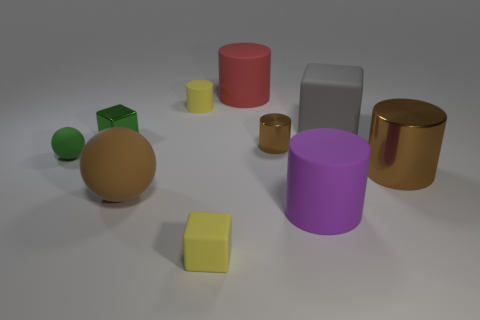What is the shape of the large purple thing that is made of the same material as the large sphere?
Your response must be concise. Cylinder. There is a big brown object that is to the right of the red object; is it the same shape as the tiny yellow object behind the yellow block?
Offer a very short reply. Yes. Are there fewer big things that are in front of the small brown metallic object than brown things that are right of the brown rubber sphere?
Your answer should be compact. No. The big object that is the same color as the large sphere is what shape?
Provide a succinct answer. Cylinder. What number of metallic things are the same size as the purple matte thing?
Keep it short and to the point. 1. Is the material of the tiny thing in front of the purple rubber cylinder the same as the purple cylinder?
Make the answer very short. Yes. Are there any big gray blocks?
Provide a short and direct response. Yes. What is the size of the red cylinder that is the same material as the big gray block?
Your answer should be compact. Large. Is there a tiny metal cube that has the same color as the tiny rubber cube?
Your answer should be very brief. No. Is the color of the tiny cylinder behind the large gray rubber thing the same as the small object on the right side of the yellow cube?
Provide a short and direct response. No. 